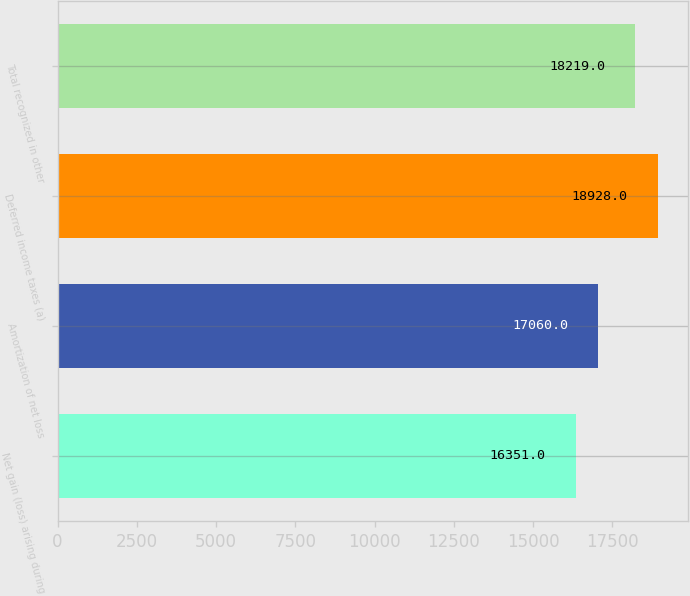Convert chart to OTSL. <chart><loc_0><loc_0><loc_500><loc_500><bar_chart><fcel>Net gain (loss) arising during<fcel>Amortization of net loss<fcel>Deferred income taxes (a)<fcel>Total recognized in other<nl><fcel>16351<fcel>17060<fcel>18928<fcel>18219<nl></chart> 